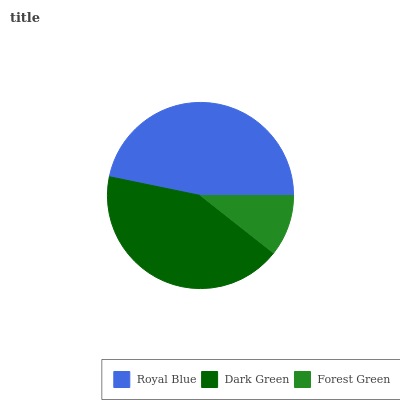Is Forest Green the minimum?
Answer yes or no. Yes. Is Royal Blue the maximum?
Answer yes or no. Yes. Is Dark Green the minimum?
Answer yes or no. No. Is Dark Green the maximum?
Answer yes or no. No. Is Royal Blue greater than Dark Green?
Answer yes or no. Yes. Is Dark Green less than Royal Blue?
Answer yes or no. Yes. Is Dark Green greater than Royal Blue?
Answer yes or no. No. Is Royal Blue less than Dark Green?
Answer yes or no. No. Is Dark Green the high median?
Answer yes or no. Yes. Is Dark Green the low median?
Answer yes or no. Yes. Is Forest Green the high median?
Answer yes or no. No. Is Royal Blue the low median?
Answer yes or no. No. 